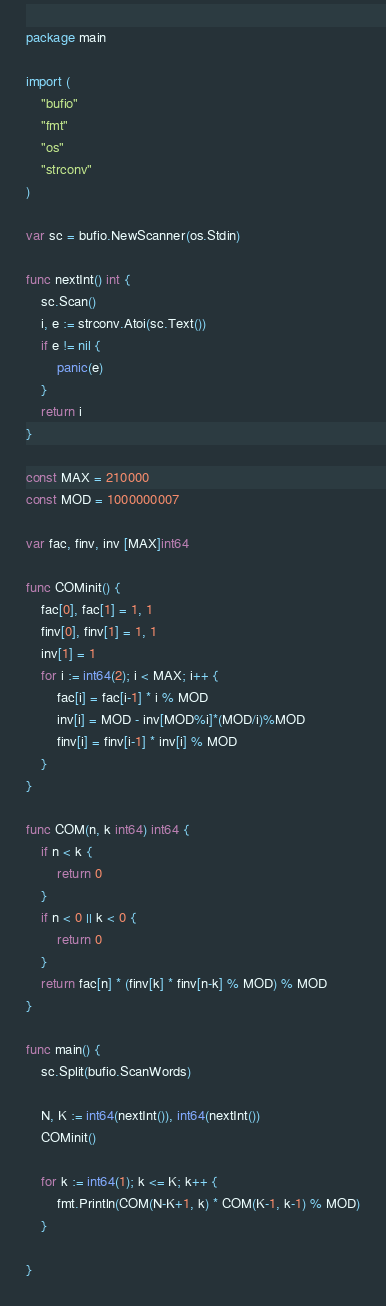Convert code to text. <code><loc_0><loc_0><loc_500><loc_500><_Go_>package main

import (
	"bufio"
	"fmt"
	"os"
	"strconv"
)

var sc = bufio.NewScanner(os.Stdin)

func nextInt() int {
	sc.Scan()
	i, e := strconv.Atoi(sc.Text())
	if e != nil {
		panic(e)
	}
	return i
}

const MAX = 210000
const MOD = 1000000007

var fac, finv, inv [MAX]int64

func COMinit() {
	fac[0], fac[1] = 1, 1
	finv[0], finv[1] = 1, 1
	inv[1] = 1
	for i := int64(2); i < MAX; i++ {
		fac[i] = fac[i-1] * i % MOD
		inv[i] = MOD - inv[MOD%i]*(MOD/i)%MOD
		finv[i] = finv[i-1] * inv[i] % MOD
	}
}

func COM(n, k int64) int64 {
	if n < k {
		return 0
	}
	if n < 0 || k < 0 {
		return 0
	}
	return fac[n] * (finv[k] * finv[n-k] % MOD) % MOD
}

func main() {
	sc.Split(bufio.ScanWords)

	N, K := int64(nextInt()), int64(nextInt())
	COMinit()

	for k := int64(1); k <= K; k++ {
		fmt.Println(COM(N-K+1, k) * COM(K-1, k-1) % MOD)
	}

}
</code> 